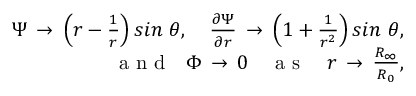Convert formula to latex. <formula><loc_0><loc_0><loc_500><loc_500>\begin{array} { r } { \Psi \, \to \, \left ( r - \frac { 1 } { r } \right ) \sin \ \theta , \quad f r a c { \partial \Psi } { \partial r } \, \to \, \left ( 1 + \frac { 1 } { r ^ { 2 } } \right ) \sin \ \theta , } \\ { a n d \quad P h i \, \to \, 0 \quad a s \quad r \, \to \, \frac { R _ { \infty } } { R _ { 0 } } , } \end{array}</formula> 